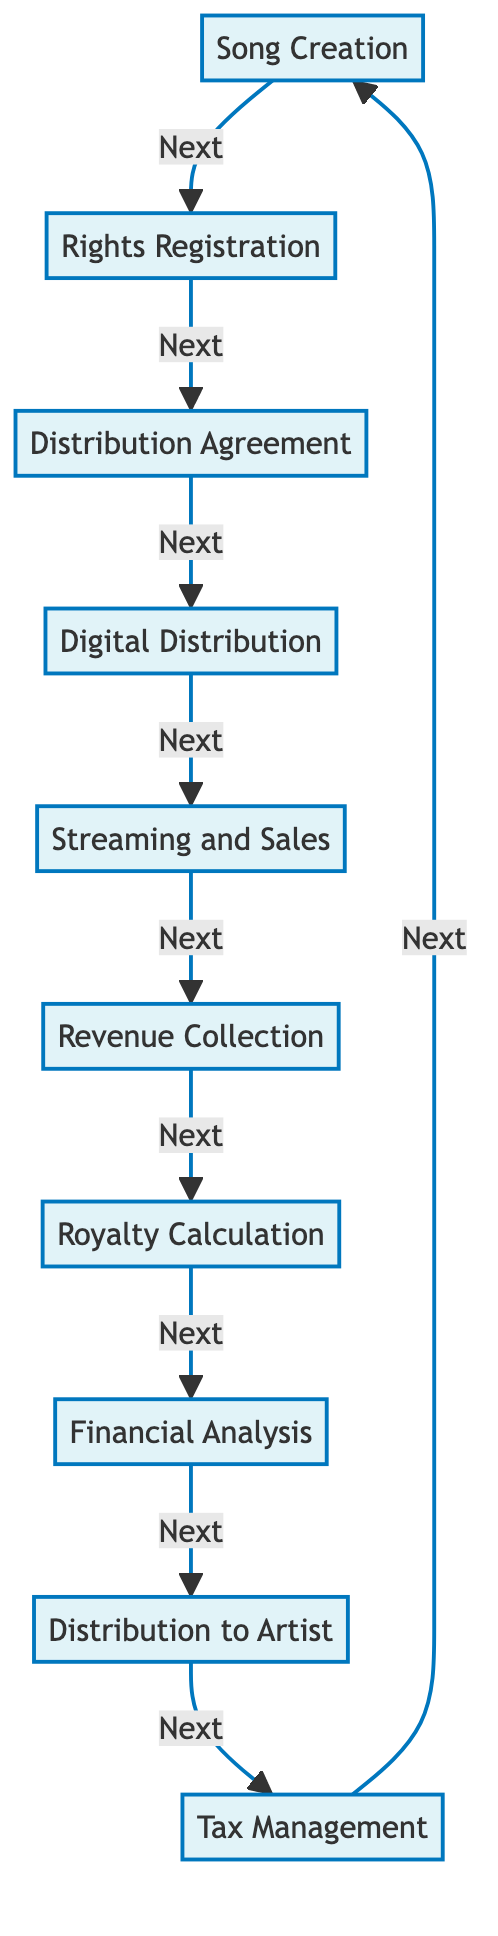What is the first step in the royalties tracking and distribution process? The diagram indicates that the process starts with "Song Creation," where the artist composes and records a new song.
Answer: Song Creation How many nodes are present in the diagram? The flowchart contains ten distinct steps that each represent a node in the royalties tracking and distribution process.
Answer: Ten What is the last step before Distribution to Artist? According to the flow of the diagram, "Financial Analysis" is the step that immediately precedes "Distribution to Artist."
Answer: Financial Analysis Which two steps are connected directly by the edge from Revenue Collection? The diagram shows that "Revenue Collection" is directly followed by "Royalty Calculation," demonstrating a clear connection between these two processes.
Answer: Royalty Calculation What action follows after Tax Management? According to the cyclical nature of the flowchart, "Tax Management" leads back to "Song Creation," indicating that the process continues in a loop.
Answer: Song Creation Which steps involve financial calculations? The steps that involve financial calculations are "Royalty Calculation" and "Financial Analysis," where royalty earnings are calculated and analyzed respectively.
Answer: Royalty Calculation and Financial Analysis What type of organizations are mentioned in the Rights Registration step? The Rights Registration step specifies that the artist must register the song with a performing rights organization, which includes ASCAP, BMI, or SESAC.
Answer: Performing rights organization Which step involves the upload of songs to distribution services? The diagram clearly indicates that "Digital Distribution" is the step where the songs are uploaded to services like CD Baby, DistroKid, or TuneCore.
Answer: Digital Distribution What is the process step that focuses on earnings collection? The step that focuses on collecting earnings from various sources is clearly labeled as "Revenue Collection" in the diagram.
Answer: Revenue Collection 